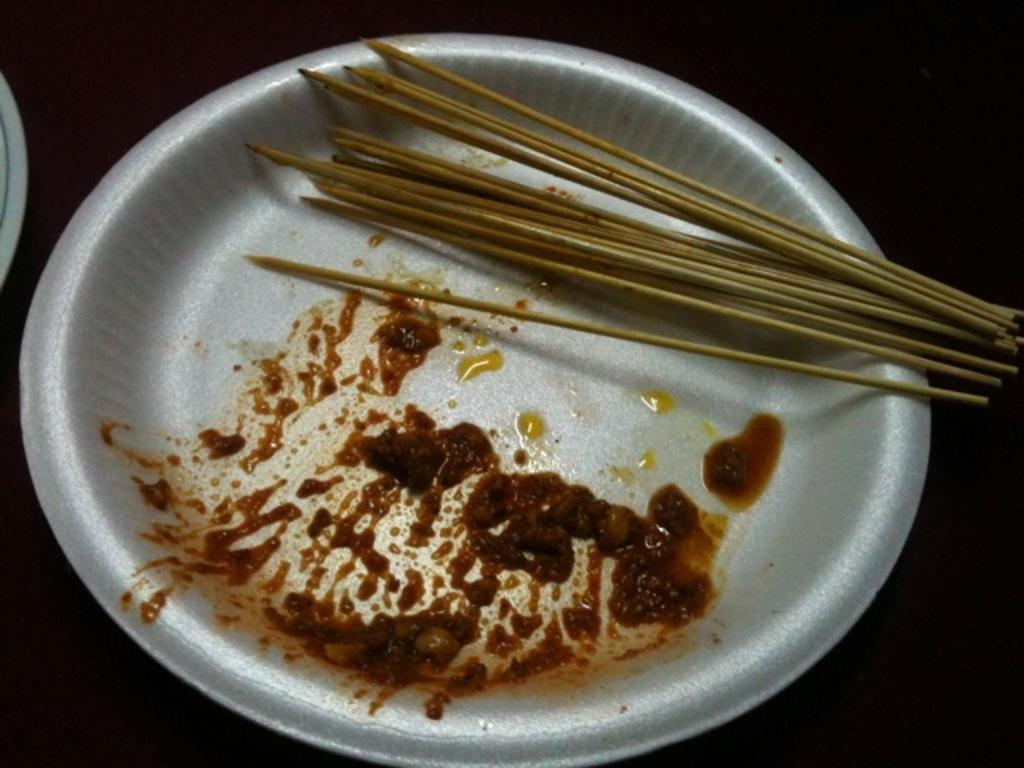What is on the plate that is visible in the image? There is food on a plate in the image. What can be seen in the left corner of the image? There is an object in the left corner of the image. How would you describe the lighting in the image? The background of the image is dark. What type of sheet is being used to cover the food in the image? There is no sheet present in the image, and the food is not covered. 